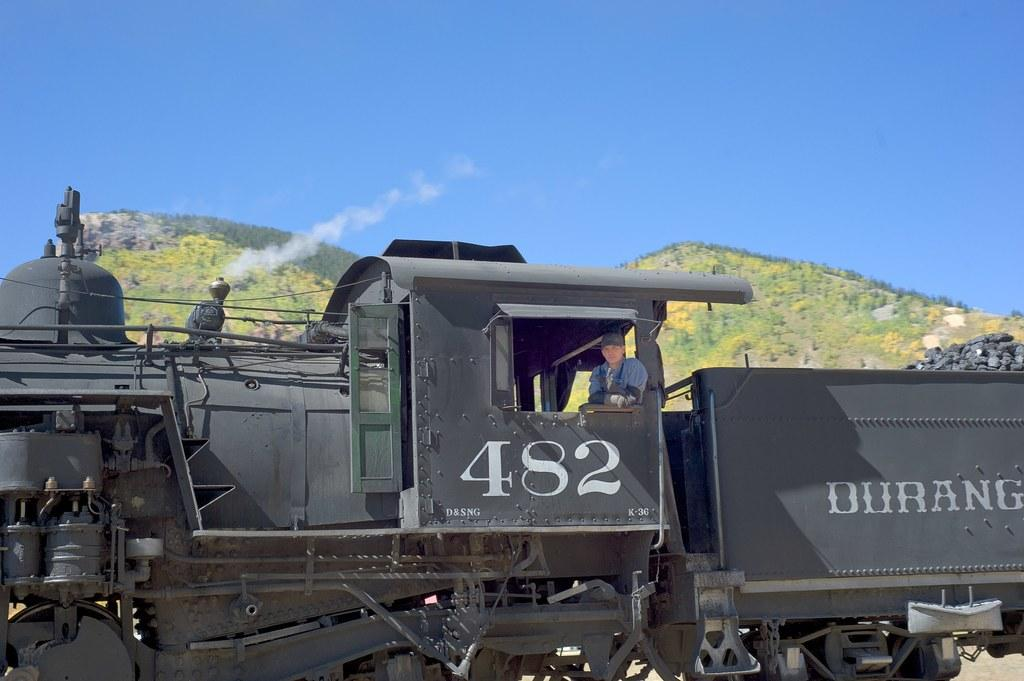What is the main subject in the foreground of the picture? There is a train in the foreground of the picture. What is being transported in the train? Coal is present in the train. Can you describe the presence of a person in the image? There is a person in the train. What can be seen in the background of the picture? There are hills in the background of the picture. What is visible at the top of the picture? The sky is visible at the top of the picture. What type of songs is the owner of the train singing in the image? There is no indication of an owner of the train in the image, nor is there any mention of songs being sung. 